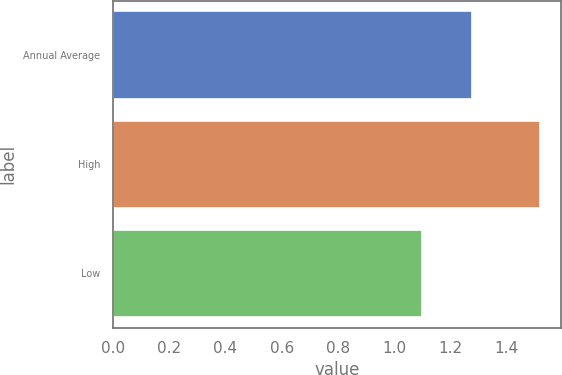Convert chart to OTSL. <chart><loc_0><loc_0><loc_500><loc_500><bar_chart><fcel>Annual Average<fcel>High<fcel>Low<nl><fcel>1.28<fcel>1.52<fcel>1.1<nl></chart> 